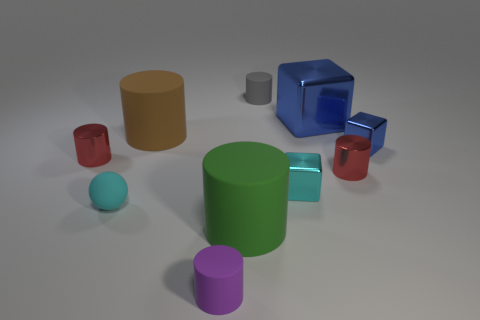Subtract all purple blocks. How many red cylinders are left? 2 Subtract 1 cylinders. How many cylinders are left? 5 Subtract all small purple rubber cylinders. How many cylinders are left? 5 Subtract all purple cylinders. How many cylinders are left? 5 Subtract all red cylinders. Subtract all red cubes. How many cylinders are left? 4 Subtract all blocks. How many objects are left? 7 Add 7 cyan objects. How many cyan objects are left? 9 Add 3 small cyan matte objects. How many small cyan matte objects exist? 4 Subtract 0 cyan cylinders. How many objects are left? 10 Subtract all tiny yellow blocks. Subtract all small gray objects. How many objects are left? 9 